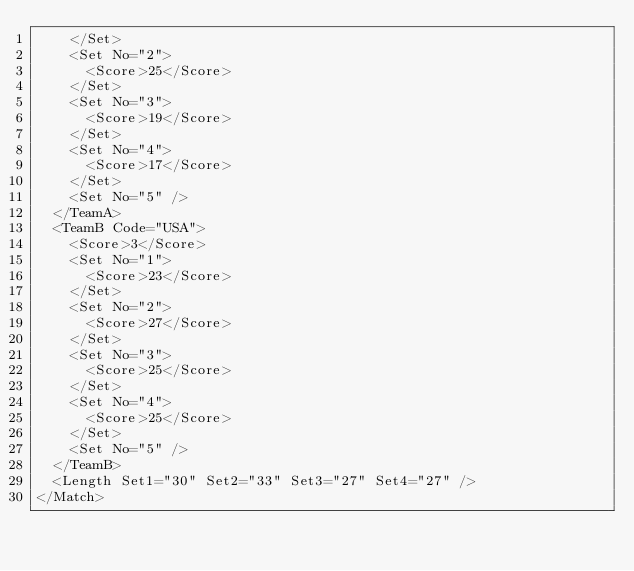Convert code to text. <code><loc_0><loc_0><loc_500><loc_500><_XML_>    </Set>
    <Set No="2">
      <Score>25</Score>
    </Set>
    <Set No="3">
      <Score>19</Score>
    </Set>
    <Set No="4">
      <Score>17</Score>
    </Set>
    <Set No="5" />
  </TeamA>
  <TeamB Code="USA">
    <Score>3</Score>
    <Set No="1">
      <Score>23</Score>
    </Set>
    <Set No="2">
      <Score>27</Score>
    </Set>
    <Set No="3">
      <Score>25</Score>
    </Set>
    <Set No="4">
      <Score>25</Score>
    </Set>
    <Set No="5" />
  </TeamB>
  <Length Set1="30" Set2="33" Set3="27" Set4="27" />
</Match></code> 